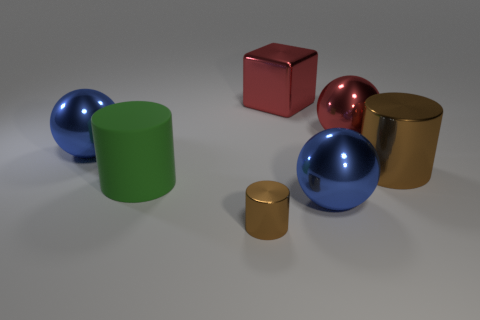What color is the metal ball that is behind the large ball left of the big rubber cylinder that is in front of the large brown shiny cylinder?
Your answer should be very brief. Red. Are there any other things that are the same material as the large red ball?
Provide a short and direct response. Yes. There is a brown object that is behind the green cylinder; is its shape the same as the big matte object?
Offer a very short reply. Yes. What is the material of the tiny brown cylinder?
Keep it short and to the point. Metal. There is a large blue object that is behind the blue thing that is to the right of the big shiny thing left of the green object; what shape is it?
Ensure brevity in your answer.  Sphere. What number of other things are the same shape as the big matte thing?
Provide a short and direct response. 2. Is the color of the tiny object the same as the cylinder that is behind the big matte object?
Keep it short and to the point. Yes. How many green things are there?
Give a very brief answer. 1. What number of objects are blue metallic objects or metal cylinders?
Make the answer very short. 4. There is a cylinder that is the same color as the tiny thing; what size is it?
Ensure brevity in your answer.  Large. 